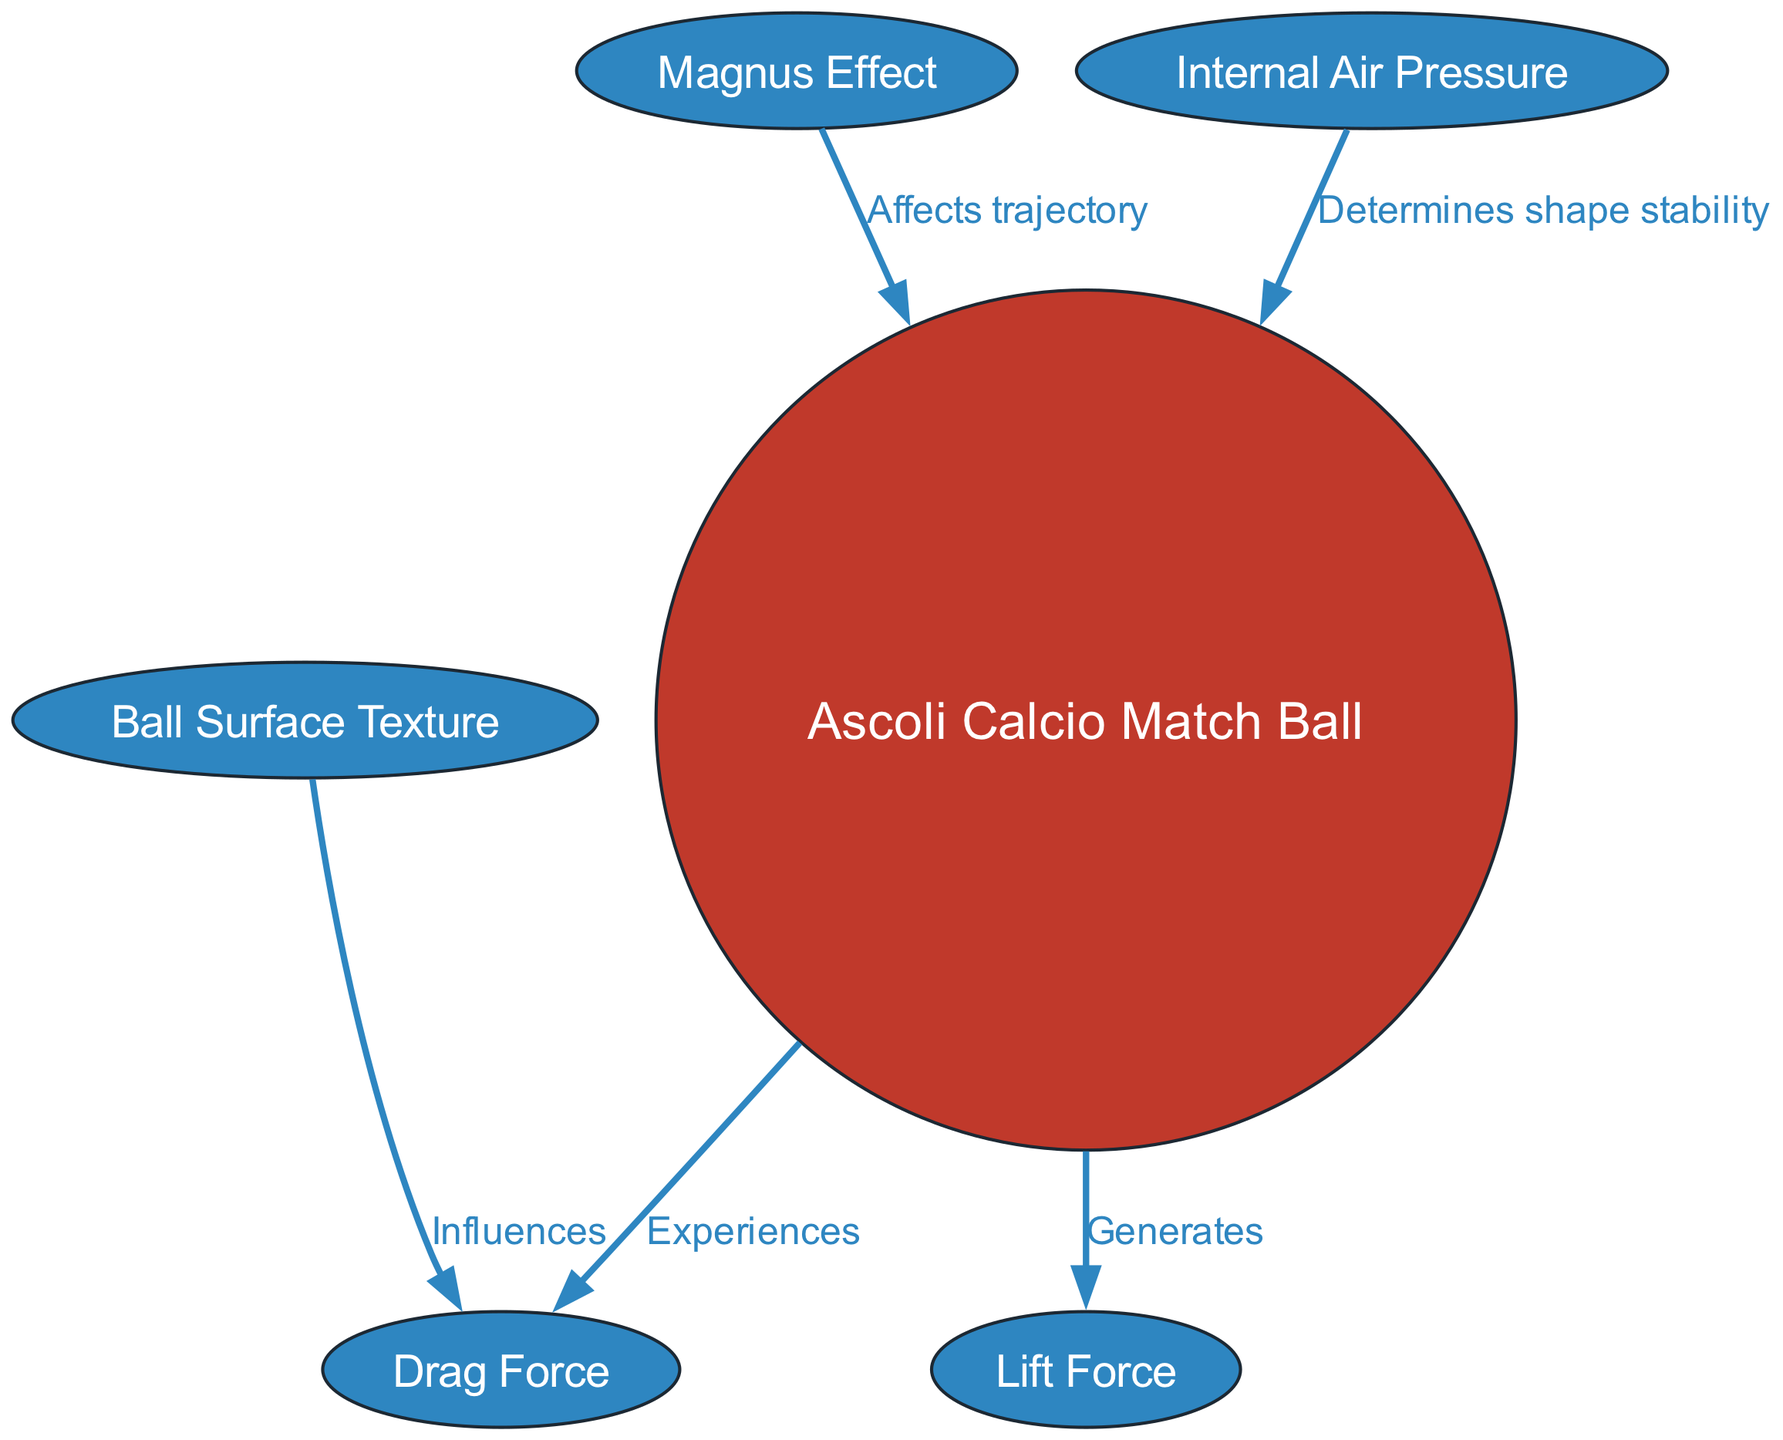What is the main object in the diagram? The diagram focuses on the "Ascoli Calcio Match Ball," which is the central node. This node is highlighted as a circle, differentiating it from other nodes that are elliptical.
Answer: Ascoli Calcio Match Ball How many nodes are present in the diagram? By counting all the individual elements connected by edges and including the main object, there are a total of six nodes represented in the diagram.
Answer: 6 What type of relationship exists between the ball and the lift force? The diagram indicates that the Ascoli Calcio Match Ball "Generates" Lift Force, suggesting a direct and positive interaction between these two entities.
Answer: Generates What force does the ball experience according to the diagram? The diagram clearly states that the ball "Experiences" Drag Force, showing that this force acts upon the ball in the opposite direction of lift.
Answer: Drag Force Which factor influences drag? According to the diagram, the "Ball Surface Texture" influences Drag Force, indicating that the texture of the ball's surface affects its aerodynamic drag properties.
Answer: Ball Surface Texture What effect does the spin have on the ball? The diagram shows that the "Magnus Effect" affects the trajectory of the ball, indicating that spinning the ball will alter its path during flight.
Answer: Affects trajectory Which factor determines the stability of the ball's shape? The diagram reveals that "Internal Air Pressure" determines the shape stability of the ball, implying that maintaining appropriate pressure is crucial for performance.
Answer: Internal Air Pressure How does the surface texture of the ball relate to drag? The diagram connects the Ball Surface Texture to Drag Force, indicating that the type of texture applied on the ball's surface plays a role in affecting how much drag is encountered during play.
Answer: Influences What is the relationship between the Magnus Effect and the ball? The diagram shows a direct relationship where the Magnus Effect "Affects trajectory," indicating that the way the ball spins will impact its course in the air.
Answer: Affects trajectory 